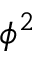Convert formula to latex. <formula><loc_0><loc_0><loc_500><loc_500>\phi ^ { 2 }</formula> 